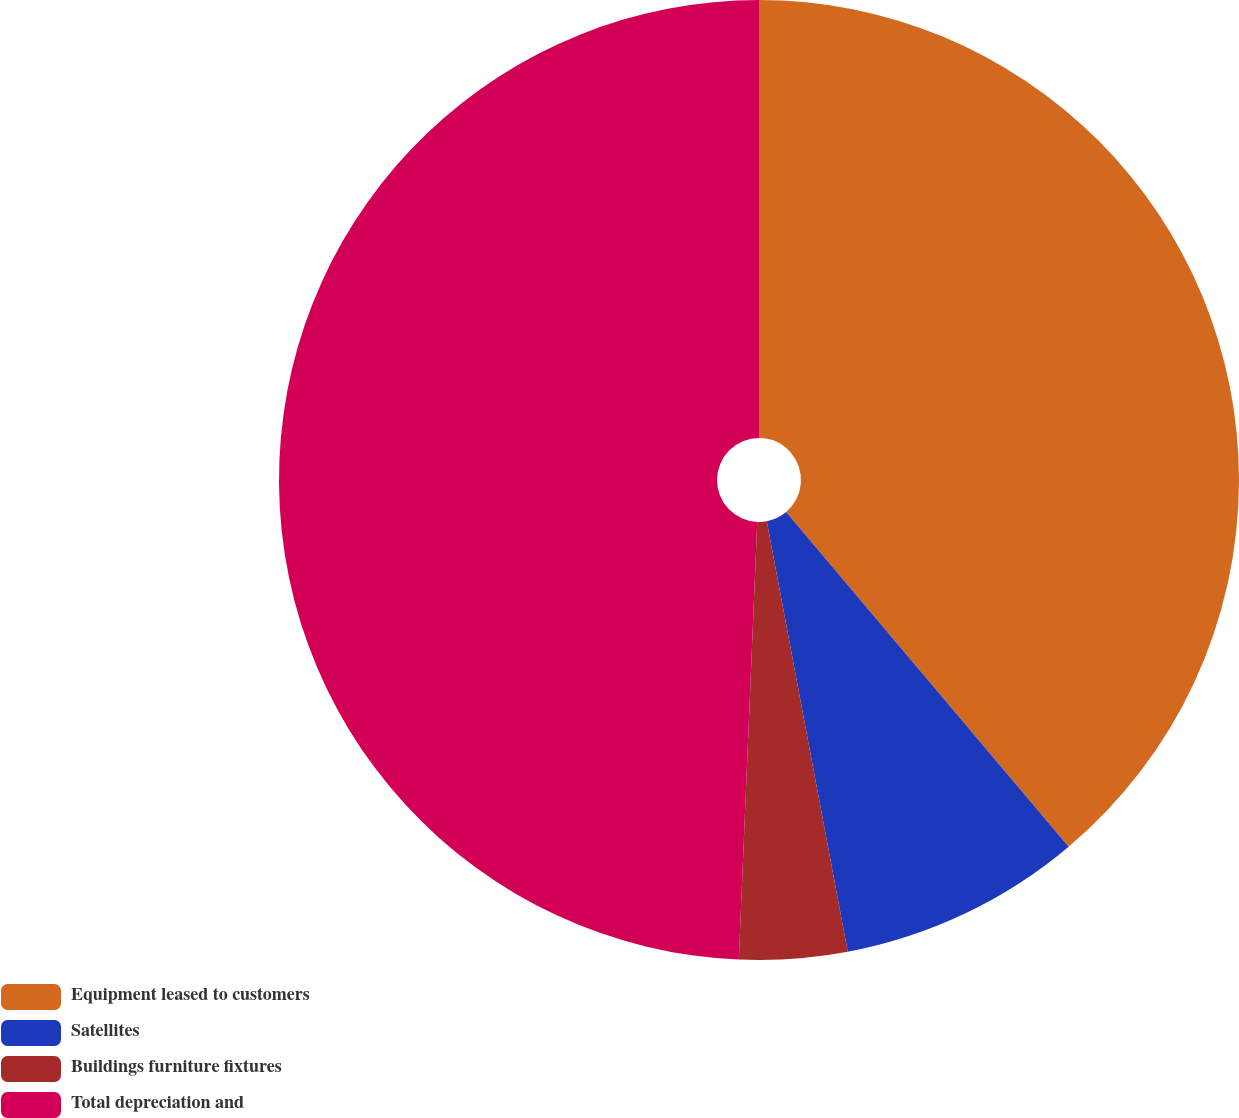<chart> <loc_0><loc_0><loc_500><loc_500><pie_chart><fcel>Equipment leased to customers<fcel>Satellites<fcel>Buildings furniture fixtures<fcel>Total depreciation and<nl><fcel>38.84%<fcel>8.2%<fcel>3.63%<fcel>49.33%<nl></chart> 